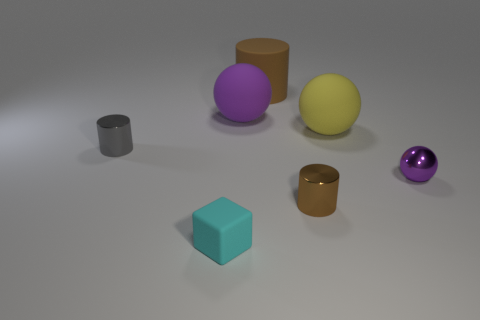Add 1 objects. How many objects exist? 8 Subtract all blocks. How many objects are left? 6 Subtract all large matte cylinders. Subtract all tiny shiny things. How many objects are left? 3 Add 1 small brown metal objects. How many small brown metal objects are left? 2 Add 7 small gray cylinders. How many small gray cylinders exist? 8 Subtract 0 blue cylinders. How many objects are left? 7 